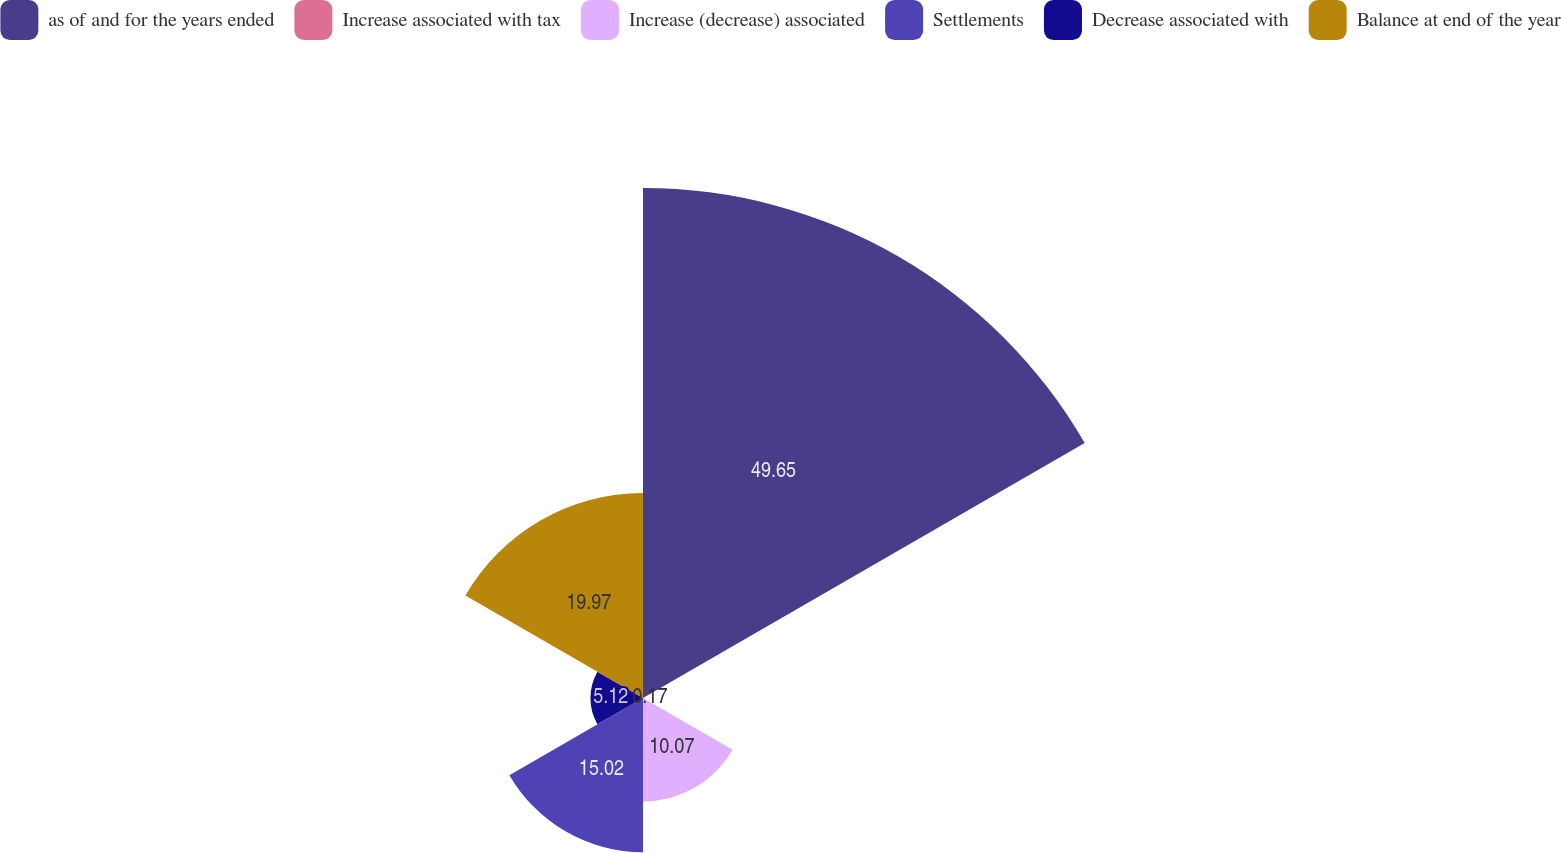Convert chart to OTSL. <chart><loc_0><loc_0><loc_500><loc_500><pie_chart><fcel>as of and for the years ended<fcel>Increase associated with tax<fcel>Increase (decrease) associated<fcel>Settlements<fcel>Decrease associated with<fcel>Balance at end of the year<nl><fcel>49.66%<fcel>0.17%<fcel>10.07%<fcel>15.02%<fcel>5.12%<fcel>19.97%<nl></chart> 